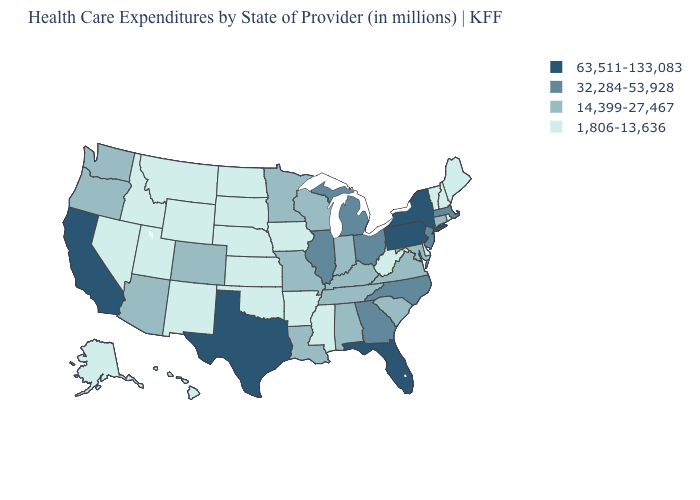Does Michigan have a lower value than Delaware?
Quick response, please. No. What is the value of New Hampshire?
Concise answer only. 1,806-13,636. Name the states that have a value in the range 14,399-27,467?
Short answer required. Alabama, Arizona, Colorado, Connecticut, Indiana, Kentucky, Louisiana, Maryland, Minnesota, Missouri, Oregon, South Carolina, Tennessee, Virginia, Washington, Wisconsin. Name the states that have a value in the range 32,284-53,928?
Give a very brief answer. Georgia, Illinois, Massachusetts, Michigan, New Jersey, North Carolina, Ohio. What is the value of Idaho?
Quick response, please. 1,806-13,636. What is the highest value in the USA?
Quick response, please. 63,511-133,083. How many symbols are there in the legend?
Keep it brief. 4. Among the states that border Iowa , which have the lowest value?
Answer briefly. Nebraska, South Dakota. What is the value of New York?
Write a very short answer. 63,511-133,083. Does California have the highest value in the West?
Answer briefly. Yes. What is the value of Hawaii?
Write a very short answer. 1,806-13,636. What is the lowest value in the MidWest?
Keep it brief. 1,806-13,636. How many symbols are there in the legend?
Give a very brief answer. 4. What is the value of Utah?
Write a very short answer. 1,806-13,636. 